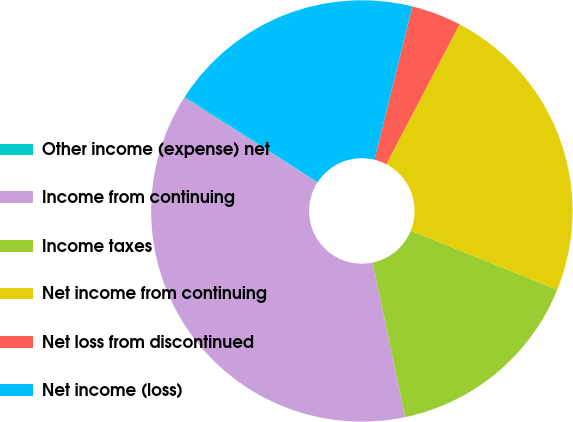<chart> <loc_0><loc_0><loc_500><loc_500><pie_chart><fcel>Other income (expense) net<fcel>Income from continuing<fcel>Income taxes<fcel>Net income from continuing<fcel>Net loss from discontinued<fcel>Net income (loss)<nl><fcel>0.11%<fcel>37.35%<fcel>15.6%<fcel>23.42%<fcel>3.83%<fcel>19.69%<nl></chart> 